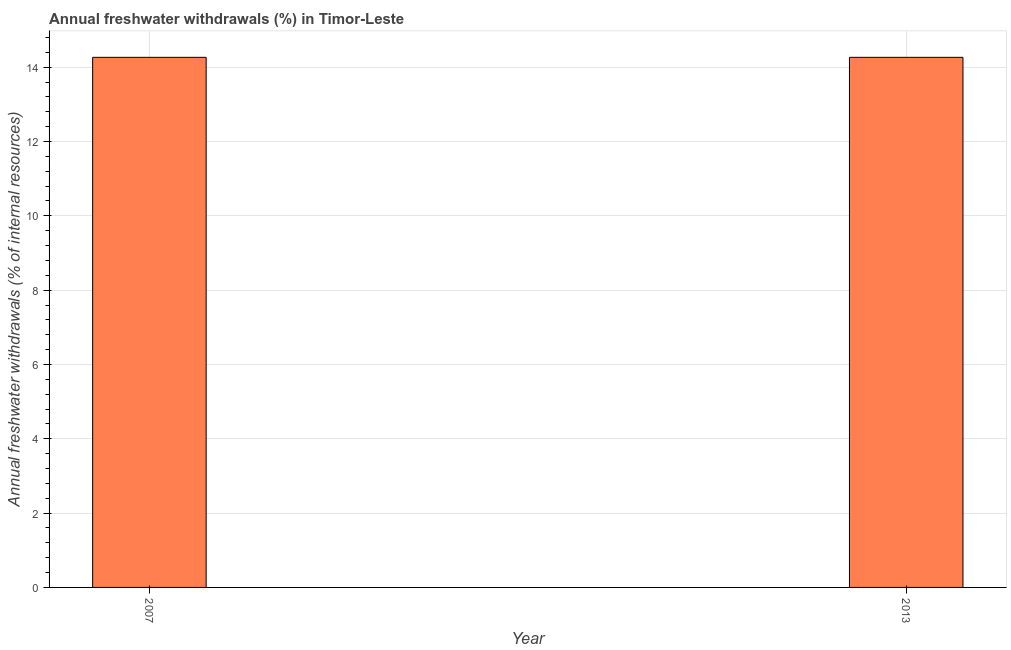Does the graph contain any zero values?
Offer a terse response. No. What is the title of the graph?
Provide a short and direct response. Annual freshwater withdrawals (%) in Timor-Leste. What is the label or title of the X-axis?
Provide a short and direct response. Year. What is the label or title of the Y-axis?
Offer a terse response. Annual freshwater withdrawals (% of internal resources). What is the annual freshwater withdrawals in 2013?
Ensure brevity in your answer.  14.27. Across all years, what is the maximum annual freshwater withdrawals?
Give a very brief answer. 14.27. Across all years, what is the minimum annual freshwater withdrawals?
Provide a succinct answer. 14.27. In which year was the annual freshwater withdrawals minimum?
Offer a terse response. 2007. What is the sum of the annual freshwater withdrawals?
Your answer should be very brief. 28.53. What is the average annual freshwater withdrawals per year?
Make the answer very short. 14.27. What is the median annual freshwater withdrawals?
Give a very brief answer. 14.27. Do a majority of the years between 2007 and 2013 (inclusive) have annual freshwater withdrawals greater than 8.4 %?
Provide a succinct answer. Yes. Is the annual freshwater withdrawals in 2007 less than that in 2013?
Your answer should be compact. No. Are all the bars in the graph horizontal?
Your response must be concise. No. How many years are there in the graph?
Give a very brief answer. 2. Are the values on the major ticks of Y-axis written in scientific E-notation?
Provide a succinct answer. No. What is the Annual freshwater withdrawals (% of internal resources) in 2007?
Your answer should be very brief. 14.27. What is the Annual freshwater withdrawals (% of internal resources) of 2013?
Your response must be concise. 14.27. What is the difference between the Annual freshwater withdrawals (% of internal resources) in 2007 and 2013?
Make the answer very short. 0. 